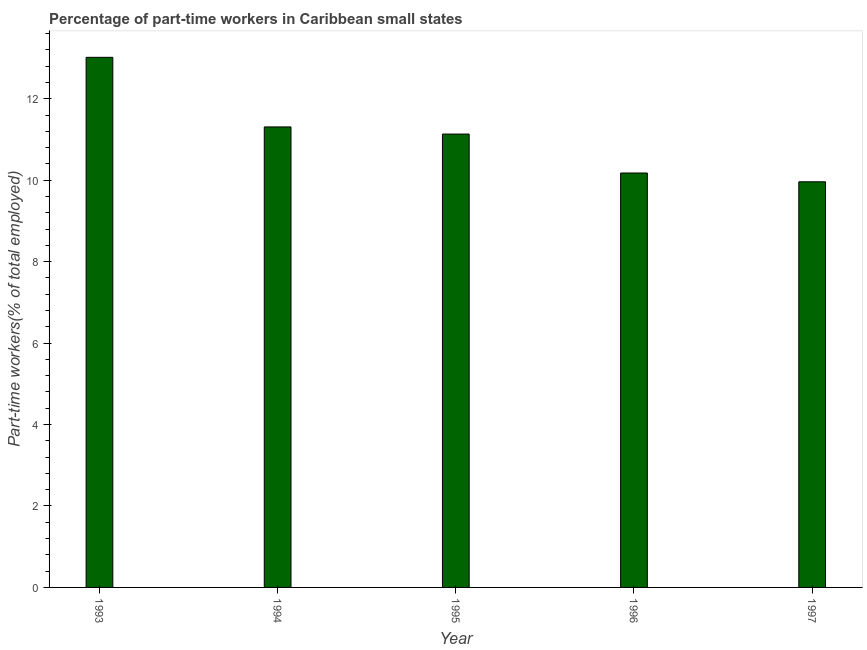Does the graph contain any zero values?
Offer a terse response. No. What is the title of the graph?
Your answer should be very brief. Percentage of part-time workers in Caribbean small states. What is the label or title of the Y-axis?
Your answer should be compact. Part-time workers(% of total employed). What is the percentage of part-time workers in 1995?
Provide a succinct answer. 11.13. Across all years, what is the maximum percentage of part-time workers?
Keep it short and to the point. 13.02. Across all years, what is the minimum percentage of part-time workers?
Provide a short and direct response. 9.96. What is the sum of the percentage of part-time workers?
Provide a short and direct response. 55.6. What is the difference between the percentage of part-time workers in 1995 and 1996?
Offer a very short reply. 0.96. What is the average percentage of part-time workers per year?
Make the answer very short. 11.12. What is the median percentage of part-time workers?
Offer a terse response. 11.13. In how many years, is the percentage of part-time workers greater than 5.6 %?
Provide a succinct answer. 5. What is the ratio of the percentage of part-time workers in 1993 to that in 1995?
Provide a short and direct response. 1.17. What is the difference between the highest and the second highest percentage of part-time workers?
Offer a terse response. 1.71. What is the difference between the highest and the lowest percentage of part-time workers?
Offer a terse response. 3.06. Are all the bars in the graph horizontal?
Your answer should be compact. No. How many years are there in the graph?
Provide a short and direct response. 5. What is the difference between two consecutive major ticks on the Y-axis?
Your answer should be compact. 2. Are the values on the major ticks of Y-axis written in scientific E-notation?
Ensure brevity in your answer.  No. What is the Part-time workers(% of total employed) of 1993?
Give a very brief answer. 13.02. What is the Part-time workers(% of total employed) in 1994?
Offer a very short reply. 11.31. What is the Part-time workers(% of total employed) in 1995?
Your answer should be compact. 11.13. What is the Part-time workers(% of total employed) of 1996?
Ensure brevity in your answer.  10.18. What is the Part-time workers(% of total employed) in 1997?
Keep it short and to the point. 9.96. What is the difference between the Part-time workers(% of total employed) in 1993 and 1994?
Give a very brief answer. 1.71. What is the difference between the Part-time workers(% of total employed) in 1993 and 1995?
Offer a terse response. 1.88. What is the difference between the Part-time workers(% of total employed) in 1993 and 1996?
Provide a succinct answer. 2.84. What is the difference between the Part-time workers(% of total employed) in 1993 and 1997?
Provide a short and direct response. 3.06. What is the difference between the Part-time workers(% of total employed) in 1994 and 1995?
Your answer should be compact. 0.17. What is the difference between the Part-time workers(% of total employed) in 1994 and 1996?
Your response must be concise. 1.13. What is the difference between the Part-time workers(% of total employed) in 1994 and 1997?
Your response must be concise. 1.35. What is the difference between the Part-time workers(% of total employed) in 1995 and 1996?
Your answer should be compact. 0.96. What is the difference between the Part-time workers(% of total employed) in 1995 and 1997?
Your response must be concise. 1.17. What is the difference between the Part-time workers(% of total employed) in 1996 and 1997?
Give a very brief answer. 0.22. What is the ratio of the Part-time workers(% of total employed) in 1993 to that in 1994?
Offer a terse response. 1.15. What is the ratio of the Part-time workers(% of total employed) in 1993 to that in 1995?
Your response must be concise. 1.17. What is the ratio of the Part-time workers(% of total employed) in 1993 to that in 1996?
Provide a short and direct response. 1.28. What is the ratio of the Part-time workers(% of total employed) in 1993 to that in 1997?
Make the answer very short. 1.31. What is the ratio of the Part-time workers(% of total employed) in 1994 to that in 1995?
Give a very brief answer. 1.02. What is the ratio of the Part-time workers(% of total employed) in 1994 to that in 1996?
Your answer should be very brief. 1.11. What is the ratio of the Part-time workers(% of total employed) in 1994 to that in 1997?
Offer a very short reply. 1.14. What is the ratio of the Part-time workers(% of total employed) in 1995 to that in 1996?
Your answer should be compact. 1.09. What is the ratio of the Part-time workers(% of total employed) in 1995 to that in 1997?
Your answer should be compact. 1.12. What is the ratio of the Part-time workers(% of total employed) in 1996 to that in 1997?
Offer a terse response. 1.02. 